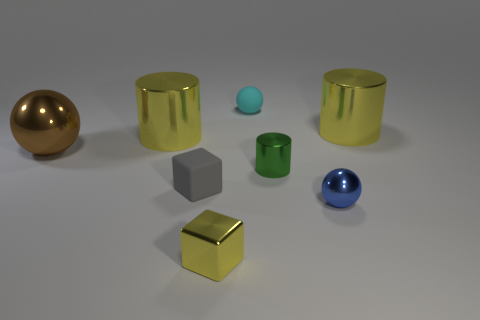What could be the function of these objects if they were real? If these objects were real, they might serve as decorative pieces due to their aesthetic appeal or possibly as components in a larger structure, where each shape could interlock or contribute uniquely to the design. Their varying sizes and shapes also suggest potential use in a didactic context, perhaps as educational tools for teaching geometry and spatial awareness. 